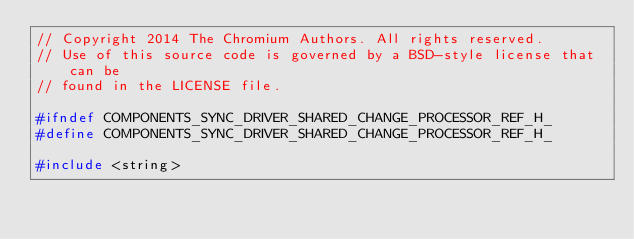<code> <loc_0><loc_0><loc_500><loc_500><_C_>// Copyright 2014 The Chromium Authors. All rights reserved.
// Use of this source code is governed by a BSD-style license that can be
// found in the LICENSE file.

#ifndef COMPONENTS_SYNC_DRIVER_SHARED_CHANGE_PROCESSOR_REF_H_
#define COMPONENTS_SYNC_DRIVER_SHARED_CHANGE_PROCESSOR_REF_H_

#include <string>
</code> 